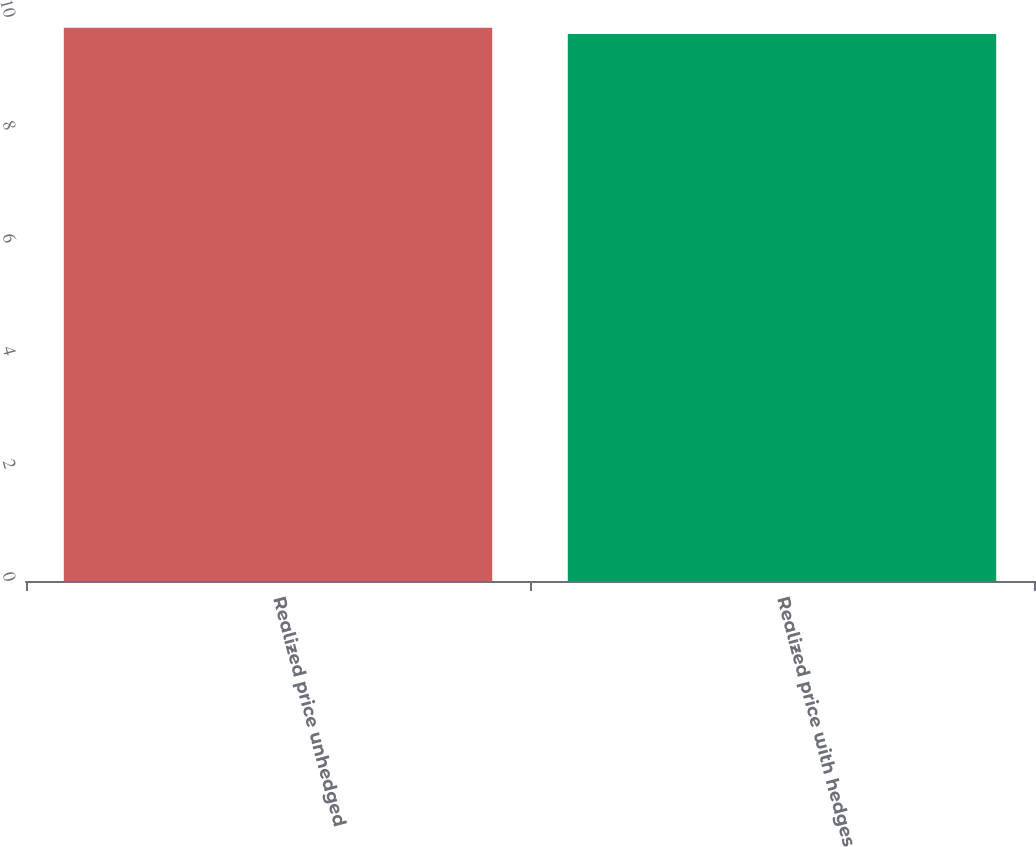Convert chart to OTSL. <chart><loc_0><loc_0><loc_500><loc_500><bar_chart><fcel>Realized price unhedged<fcel>Realized price with hedges<nl><fcel>9.81<fcel>9.7<nl></chart> 